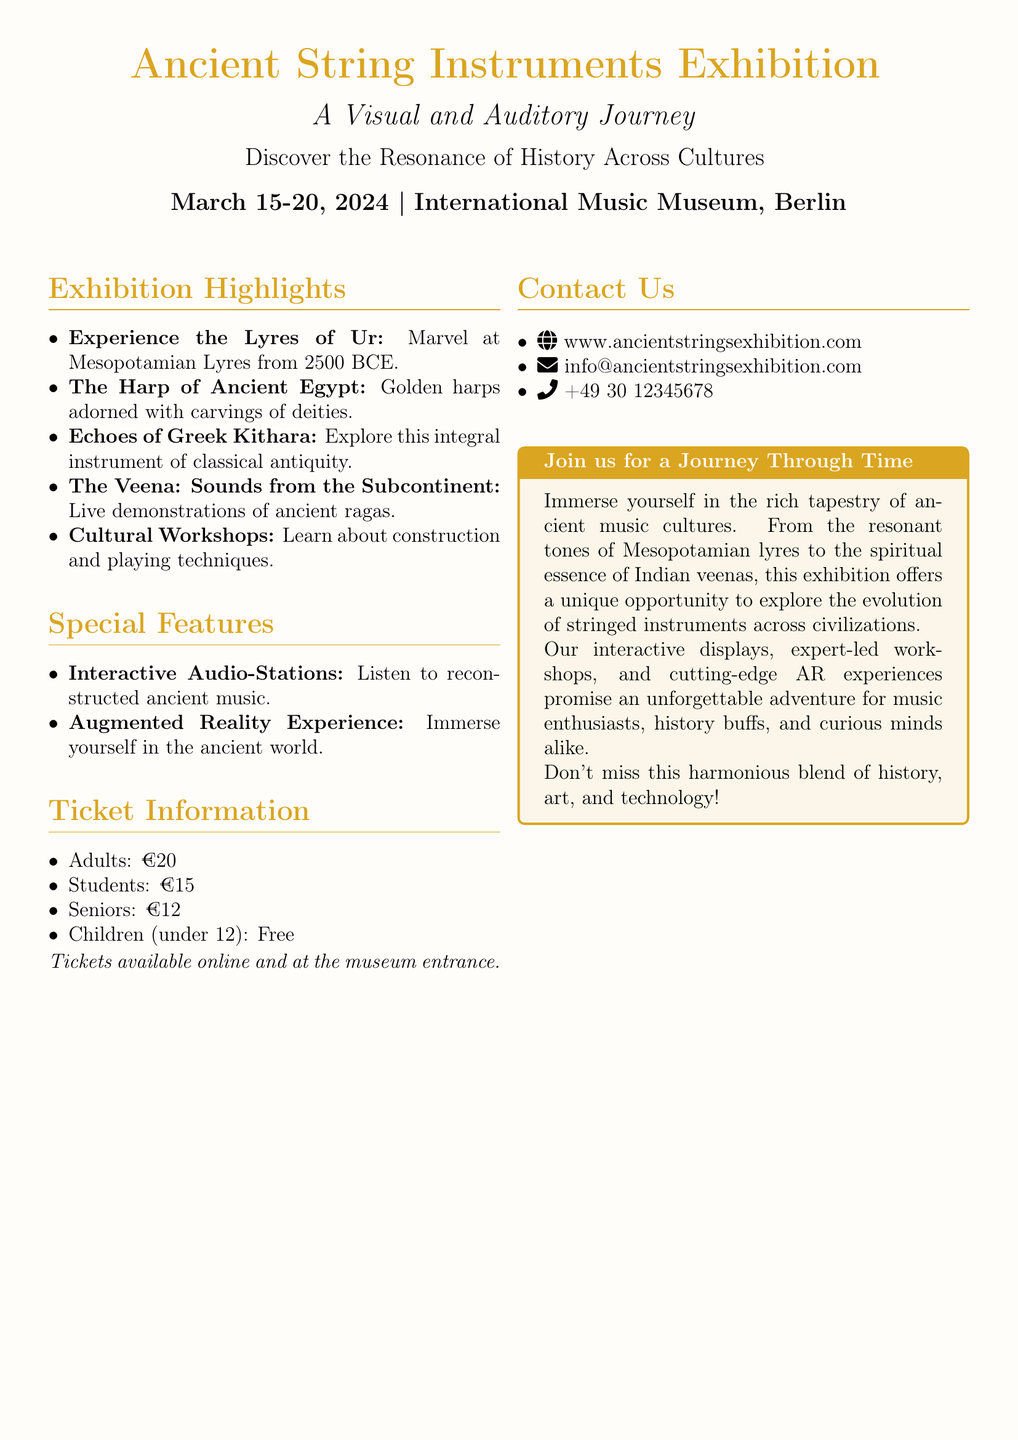What are the dates of the exhibition? The document specifies that the exhibition runs from March 15 to March 20, 2024.
Answer: March 15-20, 2024 Where is the exhibition taking place? The exhibition location is mentioned as the International Music Museum, Berlin.
Answer: International Music Museum, Berlin What is the cost of a ticket for adults? The ticket information indicates that adults need to pay €20 for entry.
Answer: €20 What ancient lyres are featured in the exhibition? The document highlights the Lyres of Ur from 2500 BCE as a key exhibit.
Answer: Lyres of Ur What type of experience is available via augmented reality? The document indicates that there is an "Augmented Reality Experience" for immersive exploration.
Answer: Augmented Reality Experience Who can enter the exhibition for free? The document states that children under 12 can enter for free.
Answer: Children (under 12) Which instrument features live demonstrations of ancient ragas? The Veena is specified as the instrument with live demonstrations of ancient ragas.
Answer: The Veena What is the email address for inquiries? The document provides the email address as info@ancientstringsexhibition.com for contacting organizers.
Answer: info@ancientstringsexhibition.com What is the purpose of the interactive audio-stations? The interactive audio-stations are intended for visitors to listen to reconstructed ancient music.
Answer: Listen to reconstructed ancient music 